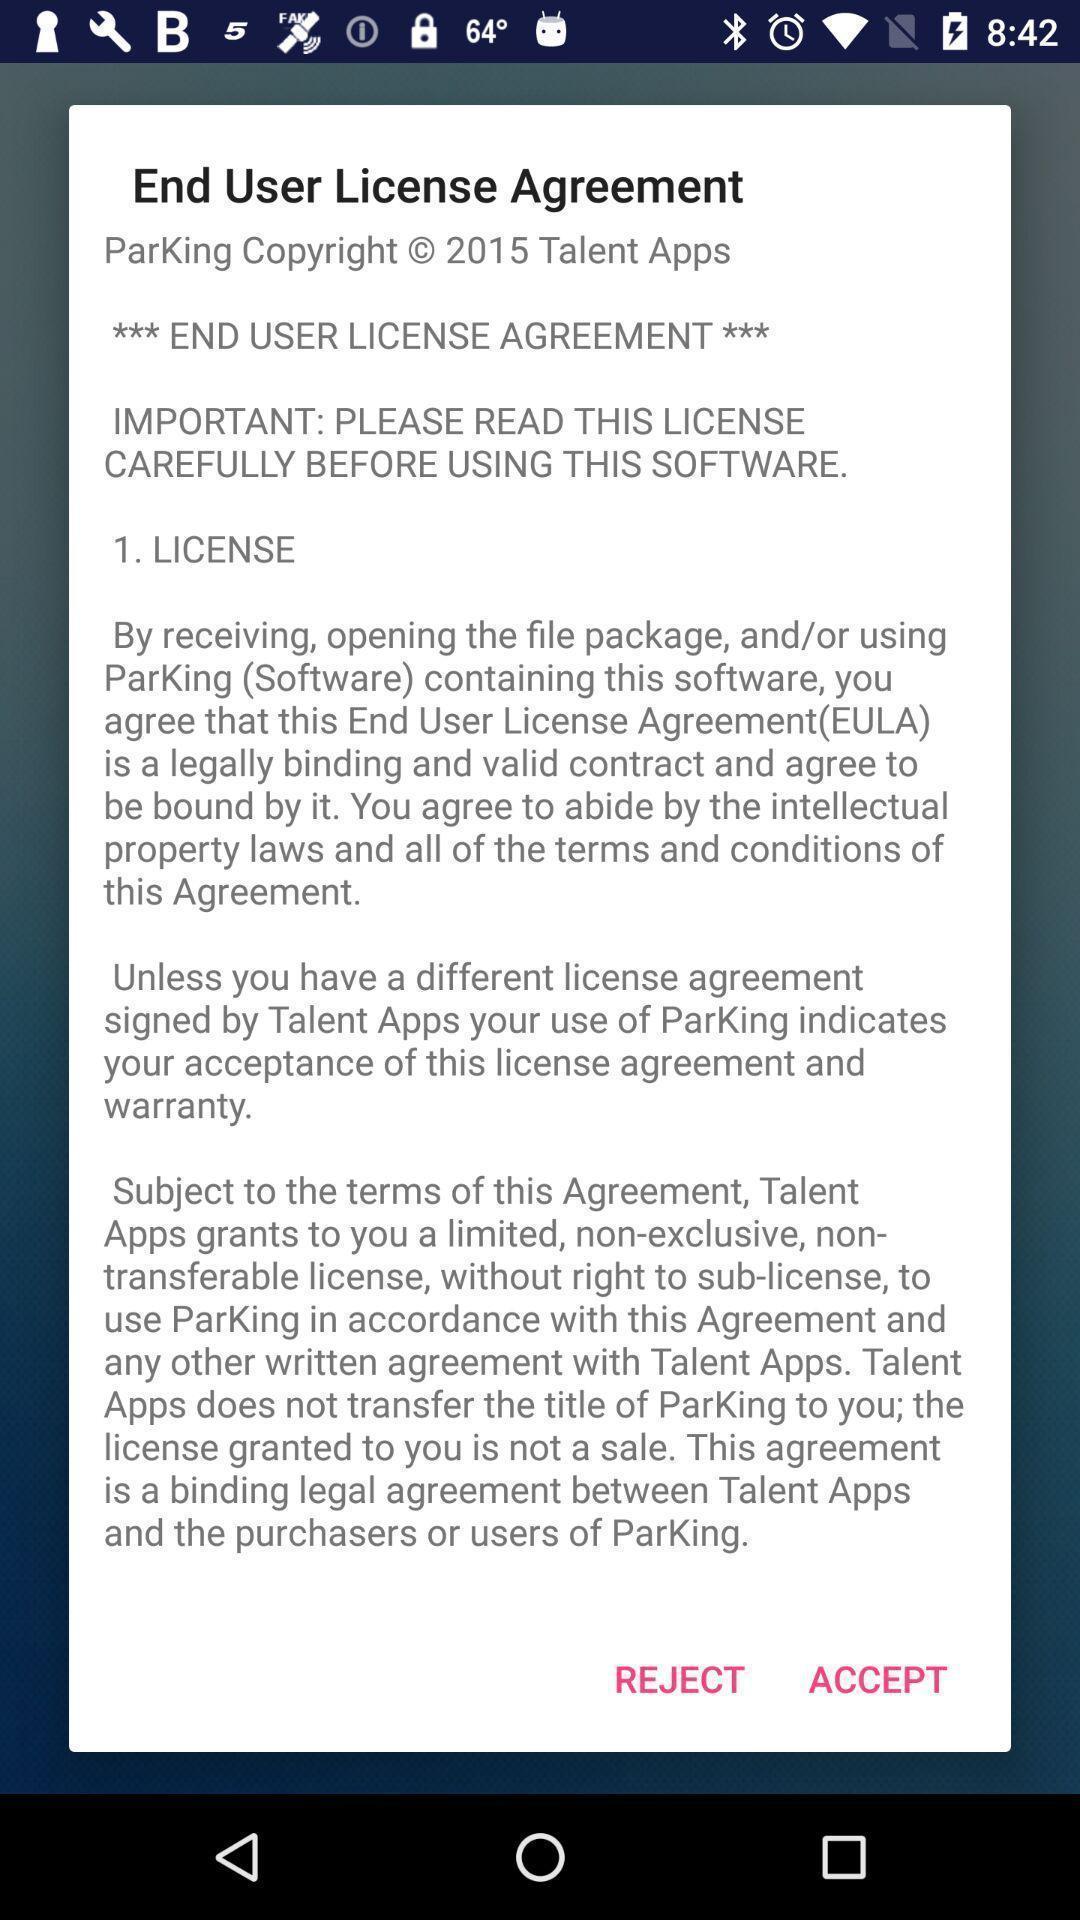What is the overall content of this screenshot? Pop up window displaying about agreement. 